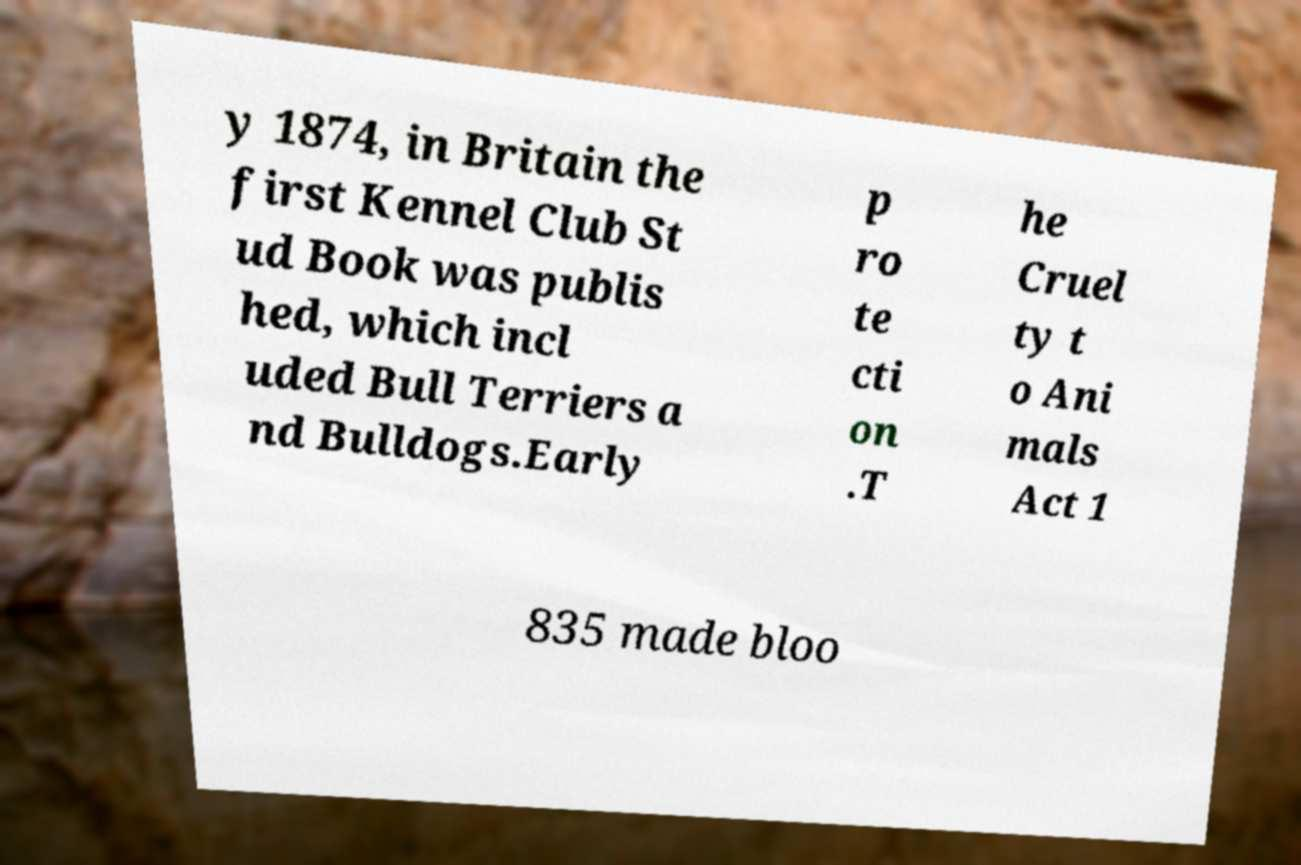What messages or text are displayed in this image? I need them in a readable, typed format. y 1874, in Britain the first Kennel Club St ud Book was publis hed, which incl uded Bull Terriers a nd Bulldogs.Early p ro te cti on .T he Cruel ty t o Ani mals Act 1 835 made bloo 